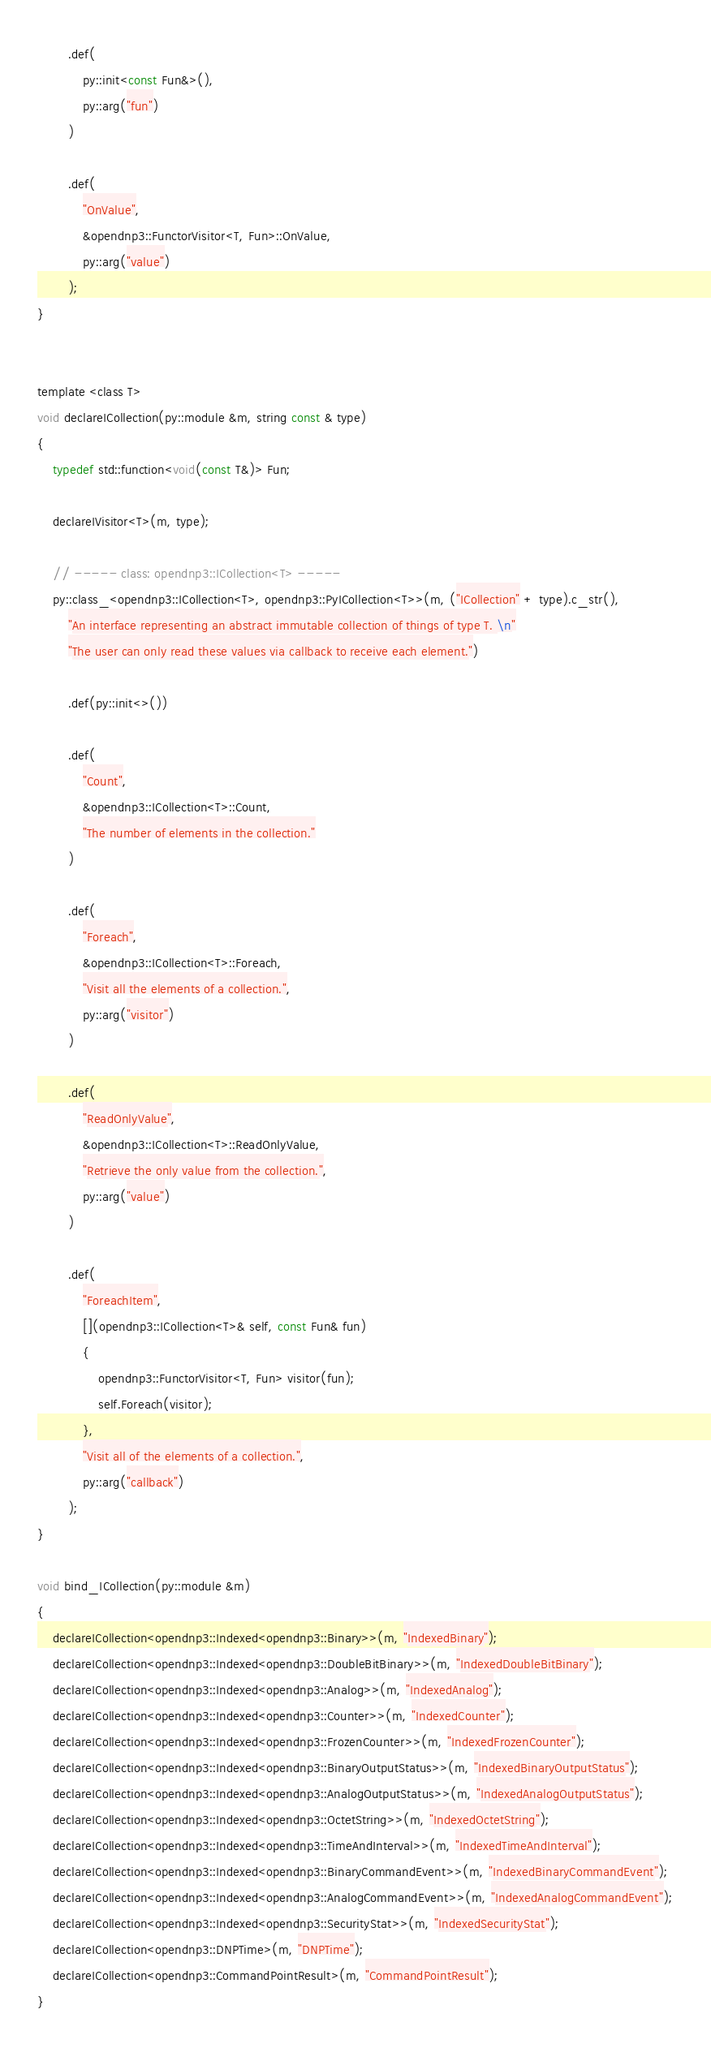Convert code to text. <code><loc_0><loc_0><loc_500><loc_500><_C_>
        .def(
            py::init<const Fun&>(),
            py::arg("fun")
        )

        .def(
            "OnValue",
            &opendnp3::FunctorVisitor<T, Fun>::OnValue,
            py::arg("value")
        );
}


template <class T>
void declareICollection(py::module &m, string const & type)
{
    typedef std::function<void(const T&)> Fun;

    declareIVisitor<T>(m, type);

    // ----- class: opendnp3::ICollection<T> -----
    py::class_<opendnp3::ICollection<T>, opendnp3::PyICollection<T>>(m, ("ICollection" + type).c_str(),
        "An interface representing an abstract immutable collection of things of type T. \n"
        "The user can only read these values via callback to receive each element.")

        .def(py::init<>())

        .def(
            "Count",
            &opendnp3::ICollection<T>::Count,
            "The number of elements in the collection."
        )

        .def(
            "Foreach",
            &opendnp3::ICollection<T>::Foreach,
            "Visit all the elements of a collection.",
            py::arg("visitor")
        )

        .def(
            "ReadOnlyValue",
            &opendnp3::ICollection<T>::ReadOnlyValue,
            "Retrieve the only value from the collection.",
            py::arg("value")
        )

        .def(
            "ForeachItem",
            [](opendnp3::ICollection<T>& self, const Fun& fun)
            {
                opendnp3::FunctorVisitor<T, Fun> visitor(fun);
                self.Foreach(visitor);
            },
            "Visit all of the elements of a collection.",
            py::arg("callback")
        );
}

void bind_ICollection(py::module &m)
{
    declareICollection<opendnp3::Indexed<opendnp3::Binary>>(m, "IndexedBinary");
    declareICollection<opendnp3::Indexed<opendnp3::DoubleBitBinary>>(m, "IndexedDoubleBitBinary");
    declareICollection<opendnp3::Indexed<opendnp3::Analog>>(m, "IndexedAnalog");
    declareICollection<opendnp3::Indexed<opendnp3::Counter>>(m, "IndexedCounter");
    declareICollection<opendnp3::Indexed<opendnp3::FrozenCounter>>(m, "IndexedFrozenCounter");
    declareICollection<opendnp3::Indexed<opendnp3::BinaryOutputStatus>>(m, "IndexedBinaryOutputStatus");
    declareICollection<opendnp3::Indexed<opendnp3::AnalogOutputStatus>>(m, "IndexedAnalogOutputStatus");
    declareICollection<opendnp3::Indexed<opendnp3::OctetString>>(m, "IndexedOctetString");
    declareICollection<opendnp3::Indexed<opendnp3::TimeAndInterval>>(m, "IndexedTimeAndInterval");
    declareICollection<opendnp3::Indexed<opendnp3::BinaryCommandEvent>>(m, "IndexedBinaryCommandEvent");
    declareICollection<opendnp3::Indexed<opendnp3::AnalogCommandEvent>>(m, "IndexedAnalogCommandEvent");
    declareICollection<opendnp3::Indexed<opendnp3::SecurityStat>>(m, "IndexedSecurityStat");
    declareICollection<opendnp3::DNPTime>(m, "DNPTime");
    declareICollection<opendnp3::CommandPointResult>(m, "CommandPointResult");
}
</code> 